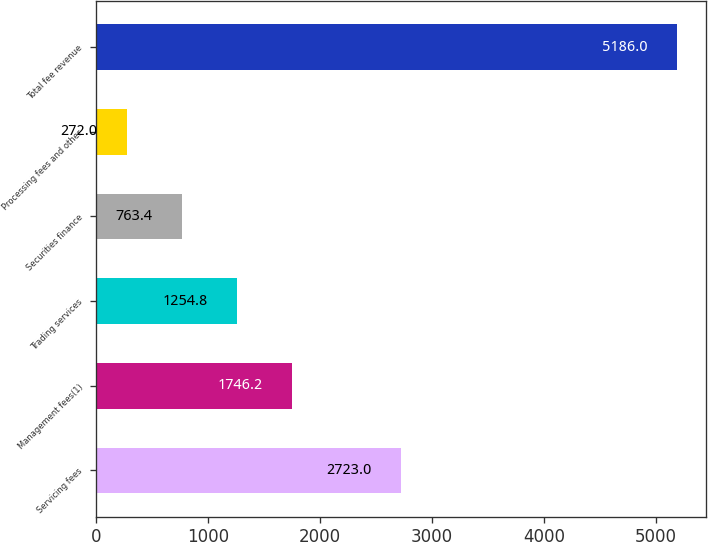Convert chart to OTSL. <chart><loc_0><loc_0><loc_500><loc_500><bar_chart><fcel>Servicing fees<fcel>Management fees(1)<fcel>Trading services<fcel>Securities finance<fcel>Processing fees and other<fcel>Total fee revenue<nl><fcel>2723<fcel>1746.2<fcel>1254.8<fcel>763.4<fcel>272<fcel>5186<nl></chart> 